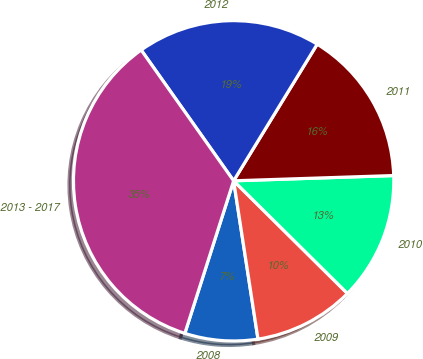Convert chart to OTSL. <chart><loc_0><loc_0><loc_500><loc_500><pie_chart><fcel>2008<fcel>2009<fcel>2010<fcel>2011<fcel>2012<fcel>2013 - 2017<nl><fcel>7.36%<fcel>10.15%<fcel>12.94%<fcel>15.74%<fcel>18.53%<fcel>35.28%<nl></chart> 